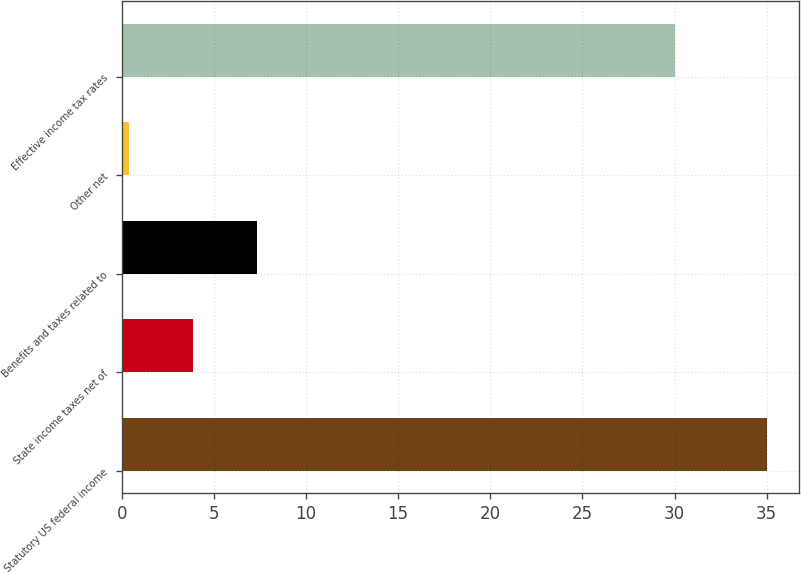<chart> <loc_0><loc_0><loc_500><loc_500><bar_chart><fcel>Statutory US federal income<fcel>State income taxes net of<fcel>Benefits and taxes related to<fcel>Other net<fcel>Effective income tax rates<nl><fcel>35<fcel>3.86<fcel>7.32<fcel>0.4<fcel>30<nl></chart> 